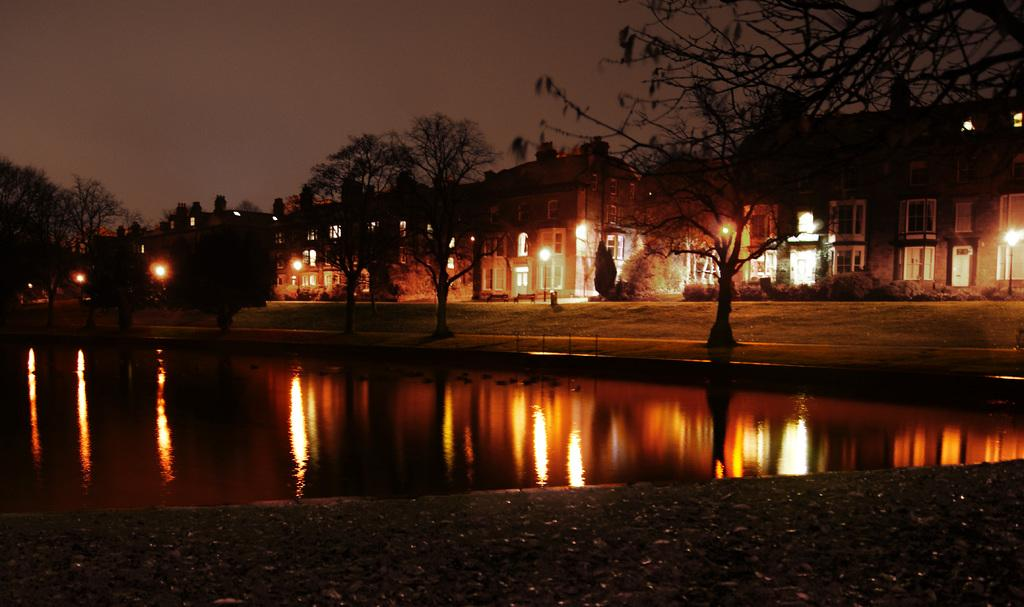What type of structures can be seen in the image? There are buildings in the image. What feature is present in the buildings? There are windows in the buildings. What are the light sources in the image? There are light poles in the image. What natural element is visible in the image? There is water visible in the image. What type of vegetation can be seen in the image? There is a plant and trees in the image. What is the weather condition in the image? The presence of a "spy" (possibly a typo for "sky") suggests that it is a clear day. What type of seating is available in the image? There are benches in the image. Can you tell me how many wires are connected to the plant in the image? There is no mention of wires connected to the plant in the image. How can I help the partner in the image? There is no partner present in the image, so it is not possible to help them. 